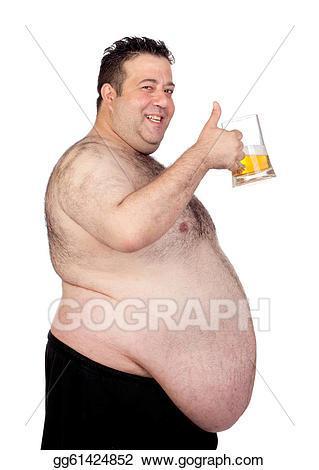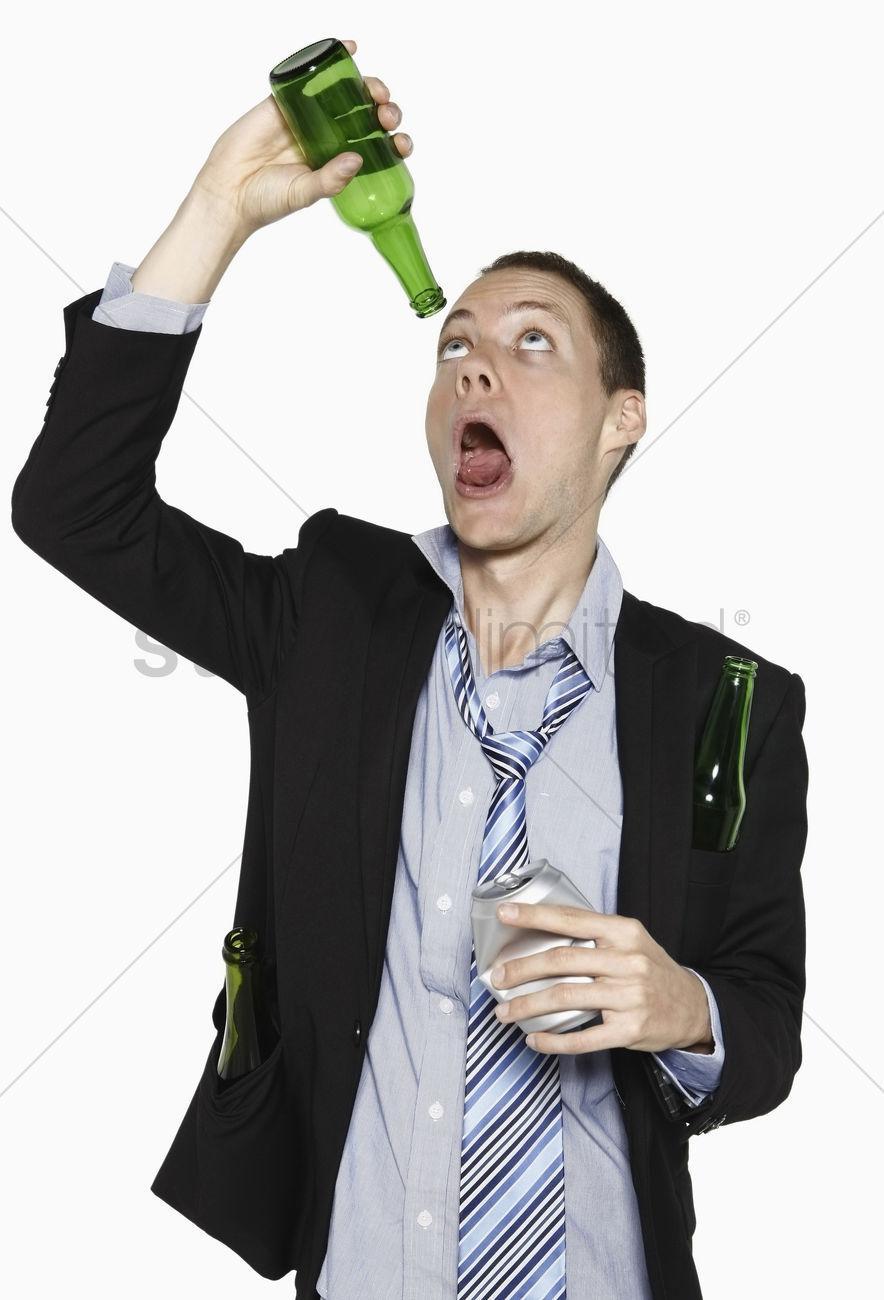The first image is the image on the left, the second image is the image on the right. Given the left and right images, does the statement "The men in both images are drinking beer, touching the bottle to their lips." hold true? Answer yes or no. No. The first image is the image on the left, the second image is the image on the right. For the images displayed, is the sentence "There are exactly two bottles." factually correct? Answer yes or no. No. 